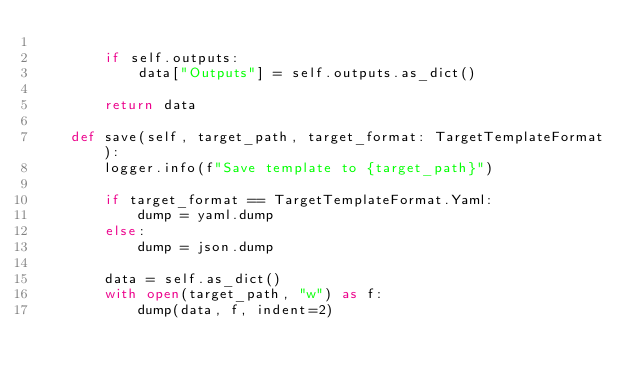Convert code to text. <code><loc_0><loc_0><loc_500><loc_500><_Python_>
        if self.outputs:
            data["Outputs"] = self.outputs.as_dict()

        return data

    def save(self, target_path, target_format: TargetTemplateFormat):
        logger.info(f"Save template to {target_path}")

        if target_format == TargetTemplateFormat.Yaml:
            dump = yaml.dump
        else:
            dump = json.dump

        data = self.as_dict()
        with open(target_path, "w") as f:
            dump(data, f, indent=2)
</code> 